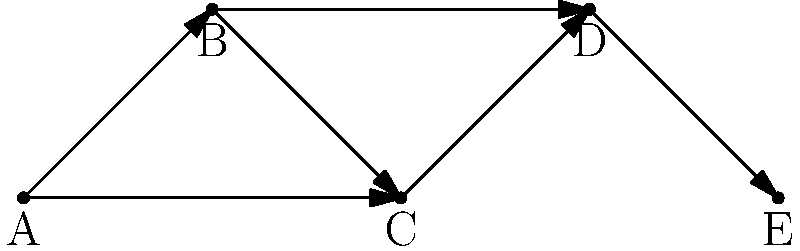Given the directed graph representing political alliances, where each node represents a political faction and each directed edge represents support from one faction to another, what is the minimum number of edges that need to be removed to disconnect node A from node E? To solve this problem, we need to analyze the paths from node A to node E:

1. First, identify all possible paths from A to E:
   Path 1: A → B → C → D → E
   Path 2: A → B → D → E
   Path 3: A → C → D → E

2. The minimum number of edges to remove is equal to the minimum number of edge-disjoint paths from A to E.

3. Observe that:
   - Path 1 and Path 2 share the edge B → D
   - Path 1 and Path 3 share the edge C → D
   - Path 2 and Path 3 are edge-disjoint

4. Therefore, there are two edge-disjoint paths from A to E:
   - A → B → D → E
   - A → C → D → E

5. To disconnect A from E, we need to remove at least one edge from each of these paths.

6. The minimum number of edges to remove is 2, which could be achieved by removing:
   - The edge A → B and the edge C → D, or
   - The edge A → C and the edge B → D

This analysis shows that even if one alliance is broken, there's still a path of influence from A to E, which could be interpreted as a resilient network of political support.
Answer: 2 edges 